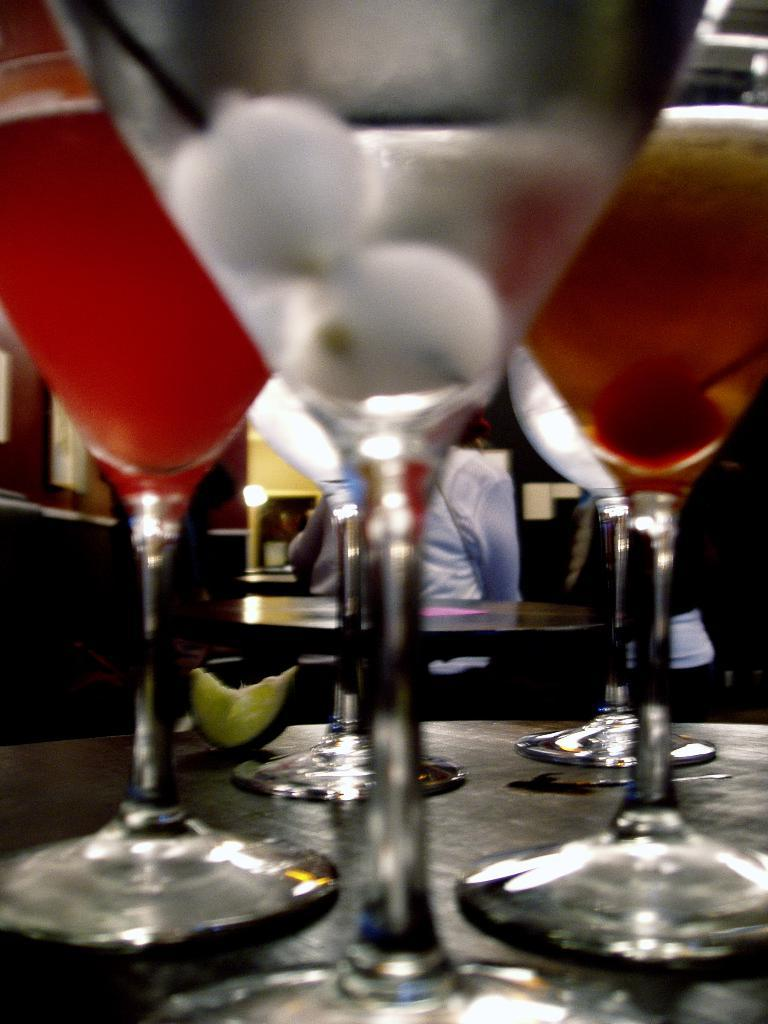What is in the glasses that are visible in the image? There are drinks in the glasses that are visible in the image. What additional items can be seen in the image? Lemon slices are present in the image. Where are the glasses and lemon slices located? The glasses and lemon slices are on a table. What else can be seen in the background of the image? There is another table and a person with a dress visible in the background of the image. How many cows are present in the image? There are no cows present in the image. What is the wealth of the person in the background of the image? The wealth of the person in the background of the image cannot be determined from the image. 